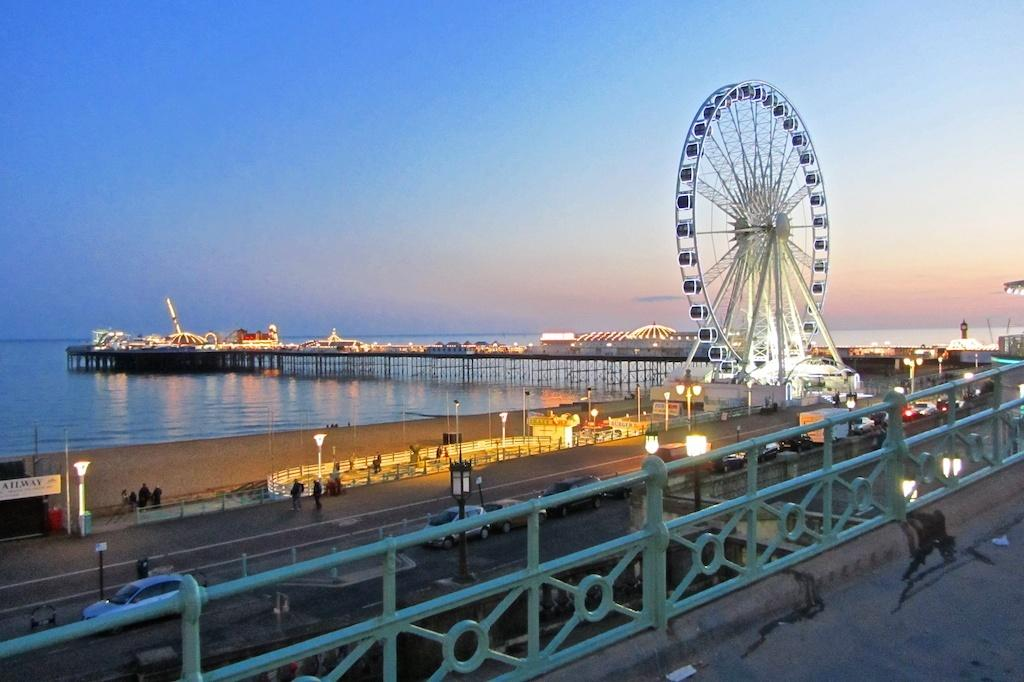What can be seen in the foreground of the image? There is a boundary in the foreground of the image. What else is present in the image? There are people, vehicles, poles, a giant wheel, and a bridge over water in the image. Can you describe the sky in the image? The sky is visible in the background of the image. What type of sweater is being worn by the people in the image? There is no information about clothing in the image, so we cannot determine if anyone is wearing a sweater. How does the harmony of the vehicles and people in the image contribute to the overall atmosphere? The image does not provide information about the harmony or atmosphere, so we cannot make any assumptions about it. 